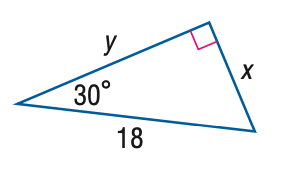Answer the mathemtical geometry problem and directly provide the correct option letter.
Question: Find y.
Choices: A: 9 B: 10.4 C: 12.7 D: 15.6 D 